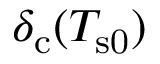<formula> <loc_0><loc_0><loc_500><loc_500>\delta _ { c } ( T _ { s 0 } )</formula> 